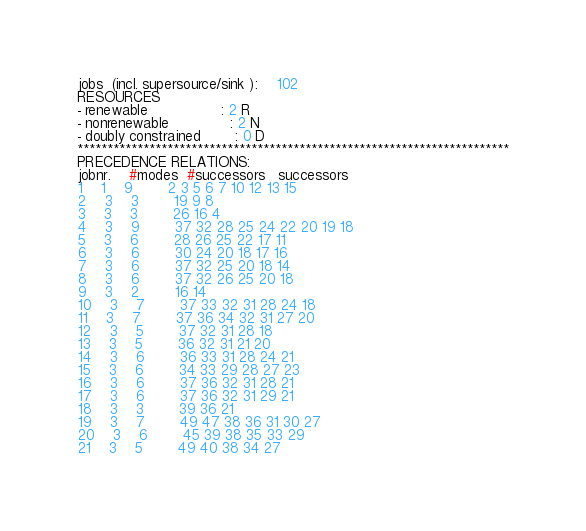<code> <loc_0><loc_0><loc_500><loc_500><_ObjectiveC_>jobs  (incl. supersource/sink ):	102
RESOURCES
- renewable                 : 2 R
- nonrenewable              : 2 N
- doubly constrained        : 0 D
************************************************************************
PRECEDENCE RELATIONS:
jobnr.    #modes  #successors   successors
1	1	9		2 3 5 6 7 10 12 13 15 
2	3	3		19 9 8 
3	3	3		26 16 4 
4	3	9		37 32 28 25 24 22 20 19 18 
5	3	6		28 26 25 22 17 11 
6	3	6		30 24 20 18 17 16 
7	3	6		37 32 25 20 18 14 
8	3	6		37 32 26 25 20 18 
9	3	2		16 14 
10	3	7		37 33 32 31 28 24 18 
11	3	7		37 36 34 32 31 27 20 
12	3	5		37 32 31 28 18 
13	3	5		36 32 31 21 20 
14	3	6		36 33 31 28 24 21 
15	3	6		34 33 29 28 27 23 
16	3	6		37 36 32 31 28 21 
17	3	6		37 36 32 31 29 21 
18	3	3		39 36 21 
19	3	7		49 47 38 36 31 30 27 
20	3	6		45 39 38 35 33 29 
21	3	5		49 40 38 34 27 </code> 